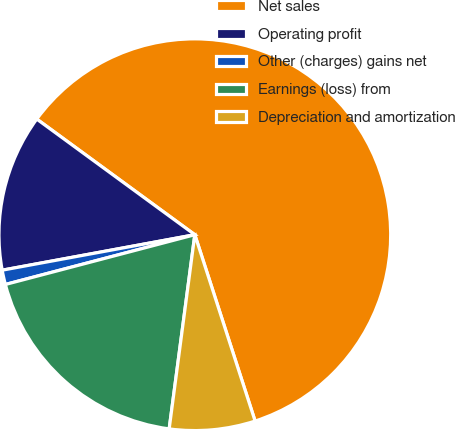Convert chart. <chart><loc_0><loc_0><loc_500><loc_500><pie_chart><fcel>Net sales<fcel>Operating profit<fcel>Other (charges) gains net<fcel>Earnings (loss) from<fcel>Depreciation and amortization<nl><fcel>59.96%<fcel>12.95%<fcel>1.19%<fcel>18.82%<fcel>7.07%<nl></chart> 